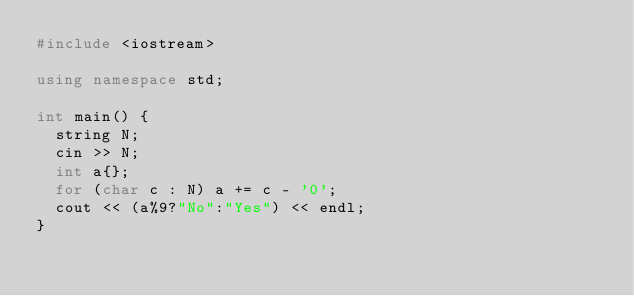Convert code to text. <code><loc_0><loc_0><loc_500><loc_500><_C++_>#include <iostream>

using namespace std;

int main() {
  string N;
  cin >> N;
  int a{};
  for (char c : N) a += c - '0';
  cout << (a%9?"No":"Yes") << endl;
}
</code> 